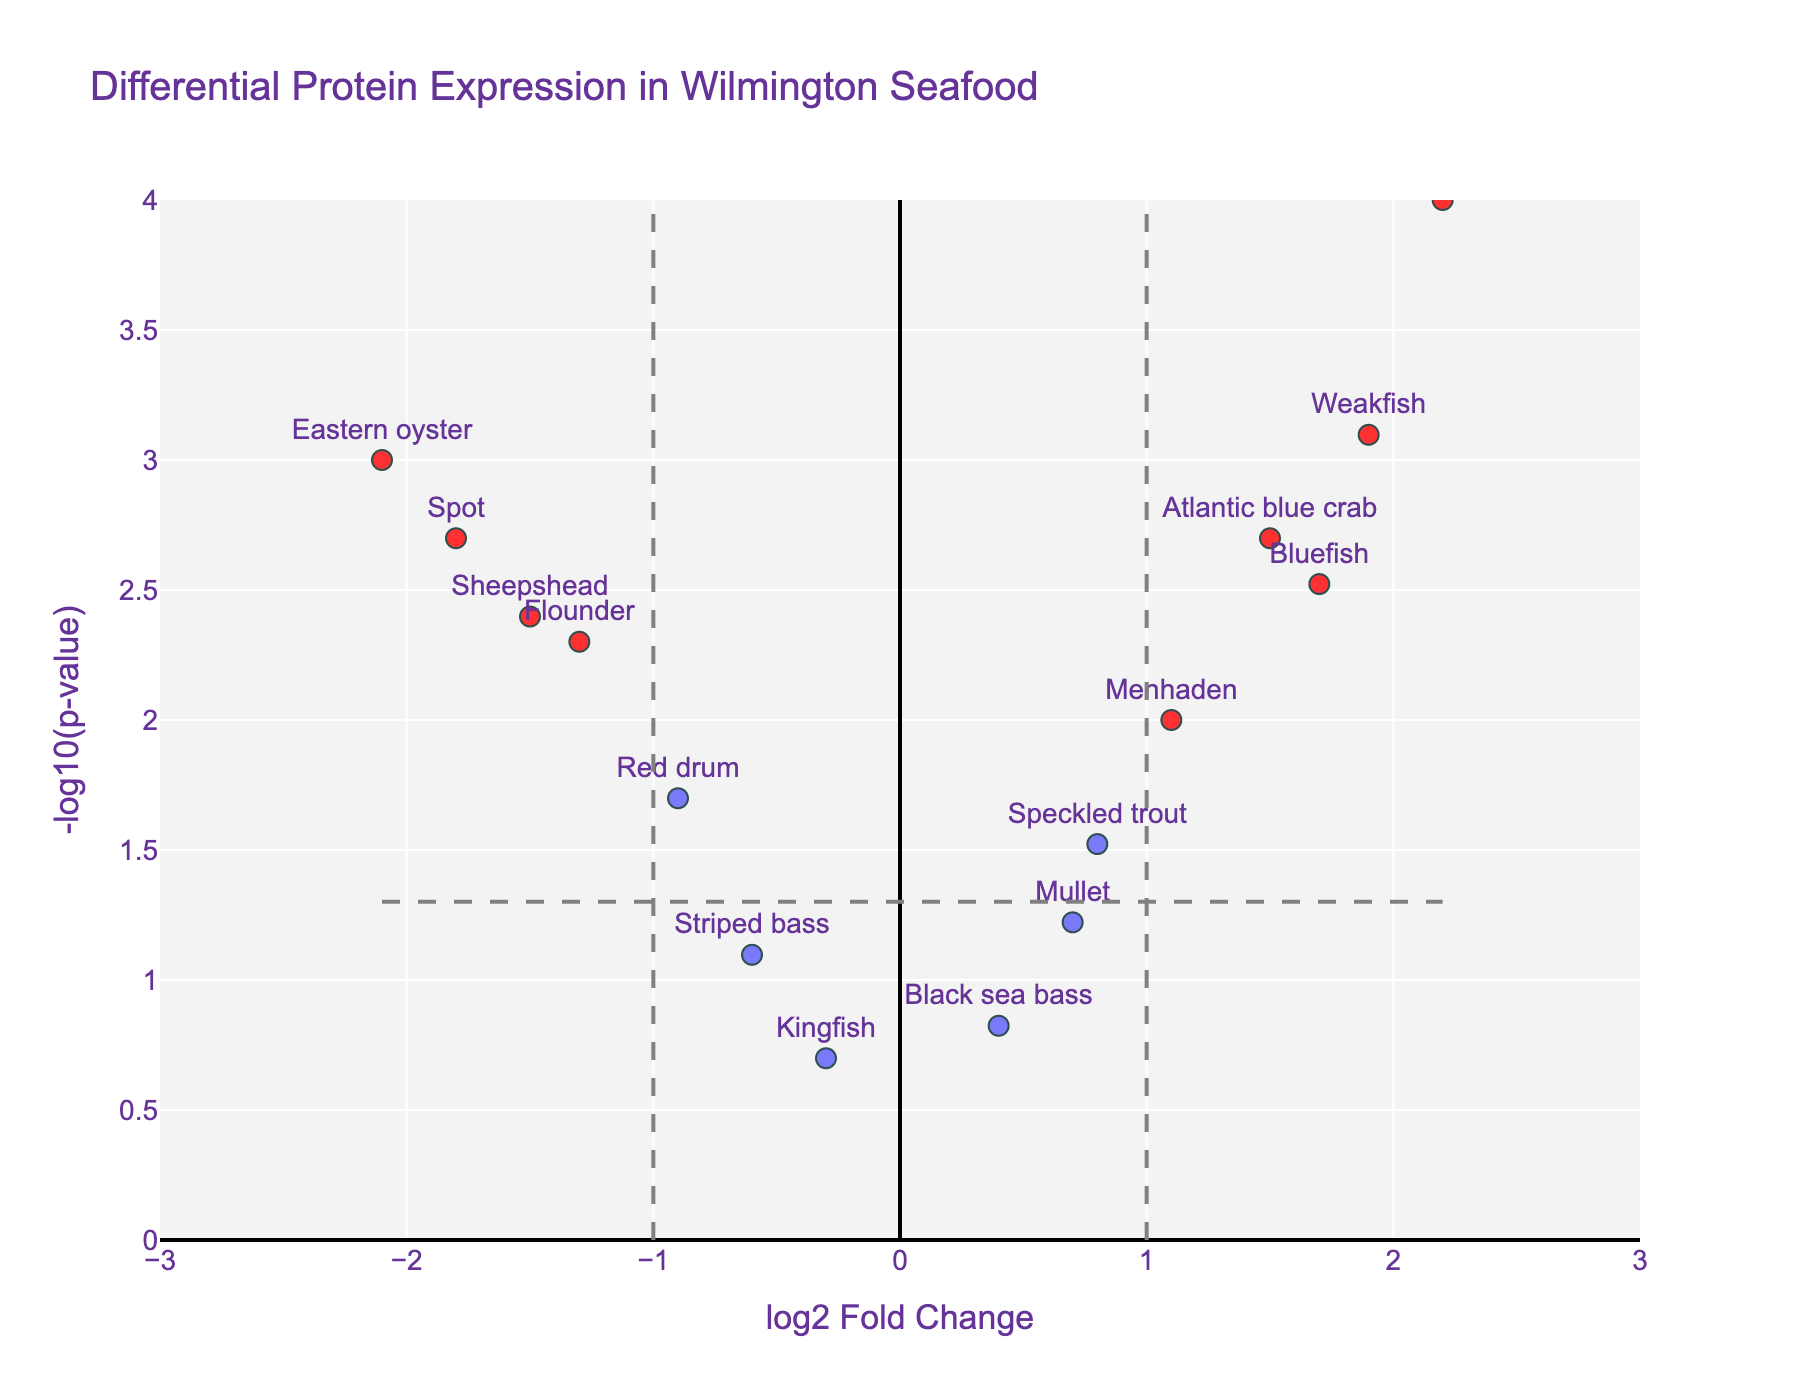How many proteins exceed the fold change threshold? The fold change threshold is set at ±1. By counting the data points visually marked with color indicating they exceed this threshold, we can determine this number. There are several data points with higher absolute fold change values than 1.
Answer: 7 Which protein shows the highest positive log2 fold change and is it significant? The x-axis represents the log2 fold change. The protein with the highest positive value on this axis is Shrimp. Its marker is also colored red, indicating significance based on the p-value.
Answer: Shrimp, yes Which protein shows the lowest p-value? The y-axis represents -log10(p-value). The highest point on this axis corresponds to the lowest p-value. The protein at this point is Shrimp.
Answer: Shrimp How many proteins have a p-value greater than 0.05? The p-value threshold is represented by a horizontal line at -log10(0.05). Proteins below this line have p-values greater than 0.05. By counting the markers below this line, this number is determined. There are three such proteins.
Answer: 3 Which protein(s) show significant upregulation? Proteins that show significant upregulation will have a positive log2 fold change (right side of the centerline) and a significant p-value (above the horizontal threshold line). The proteins that meet these criteria are Shrimp, Weakfish, and Bluefish.
Answer: Shrimp, Weakfish, Bluefish Identify any proteins with a negative log2 fold change but not statistically significant. Proteins with a negative log2 fold change are to the left of the centerline. Those not above the -log10(0.05) threshold are not statistically significant. By locating these, we find Striped bass and Mullet.
Answer: Striped bass, Mullet Which proteins have a log2 fold change between -2 and -1? On the x-axis, -2 to -1 range includes proteins with values within this range. These proteins are Eastern oyster, Flounder, Spot, Sheepshead, Red drum.
Answer: Eastern oyster, Flounder, Spot, Sheepshead, Red drum What's the range of -log10(p-value) across all proteins? The range is found by noting the minimum and maximum values on the y-axis. The minimum is near 0, and the maximum is around 4.
Answer: 0 to 4 Which protein closest to the y-axis but still significant? The y-axis represents log2 fold change. The protein closest to the y-axis (log2 fold change close to 0) and significant (above the horizontal threshold line) is Speckled trout.
Answer: Speckled trout Are there any proteins marked significant but show less than 50% change in levels? To have less than 50% change (log2 fold change < ±0.58), we need to find the proteins with log2 fold change within this range and are significant (above the threshold line). There are no such proteins.
Answer: No 